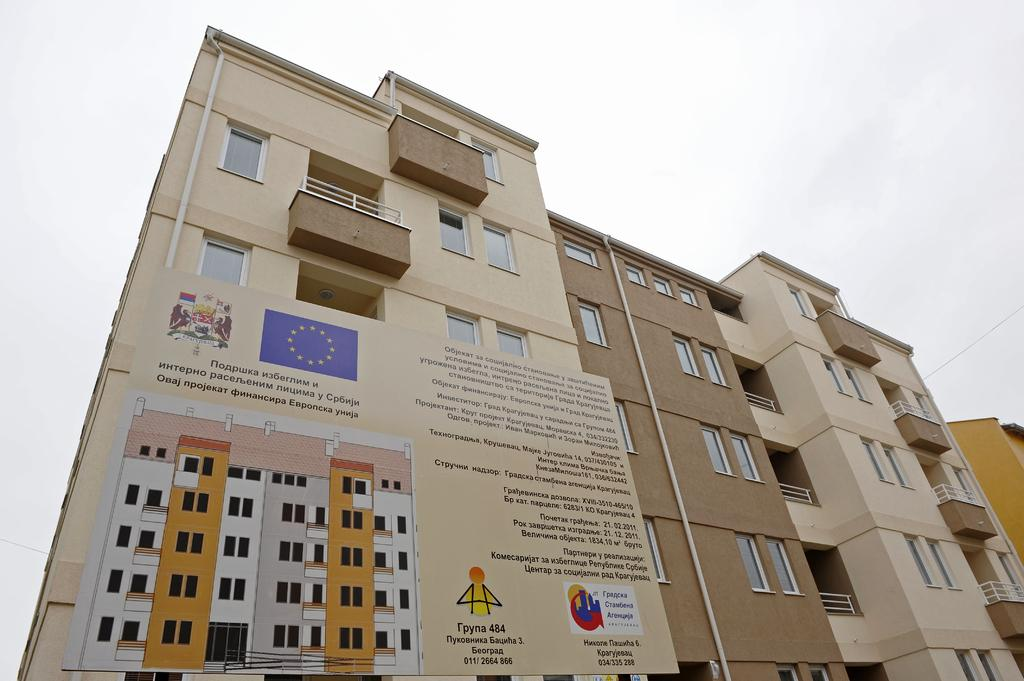What type of structures are present in the image? There are buildings in the image. What colors can be seen on the buildings? The buildings have cream, brown, and yellow colors. Is there any additional feature attached to one of the buildings? Yes, there is a board attached to one of the buildings. What is the color of the sky in the background? The sky in the background is white. What type of quartz can be seen in the image? There is no quartz present in the image. Is there a spy visible in the image? There is no indication of a spy or any person in the image. 